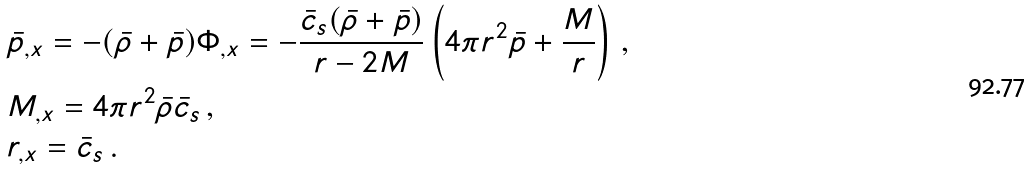Convert formula to latex. <formula><loc_0><loc_0><loc_500><loc_500>& \bar { p } _ { , x } = - ( \bar { \rho } + \bar { p } ) \Phi _ { , x } = - \frac { \bar { c } _ { s } ( \bar { \rho } + \bar { p } ) } { r - 2 M } \left ( 4 \pi r ^ { 2 } \bar { p } + \frac { M } { r } \right ) \, , \\ & M _ { , x } = 4 \pi r ^ { 2 } \bar { \rho } \bar { c } _ { s } \, , \\ & r _ { , x } = \bar { c } _ { s } \, .</formula> 